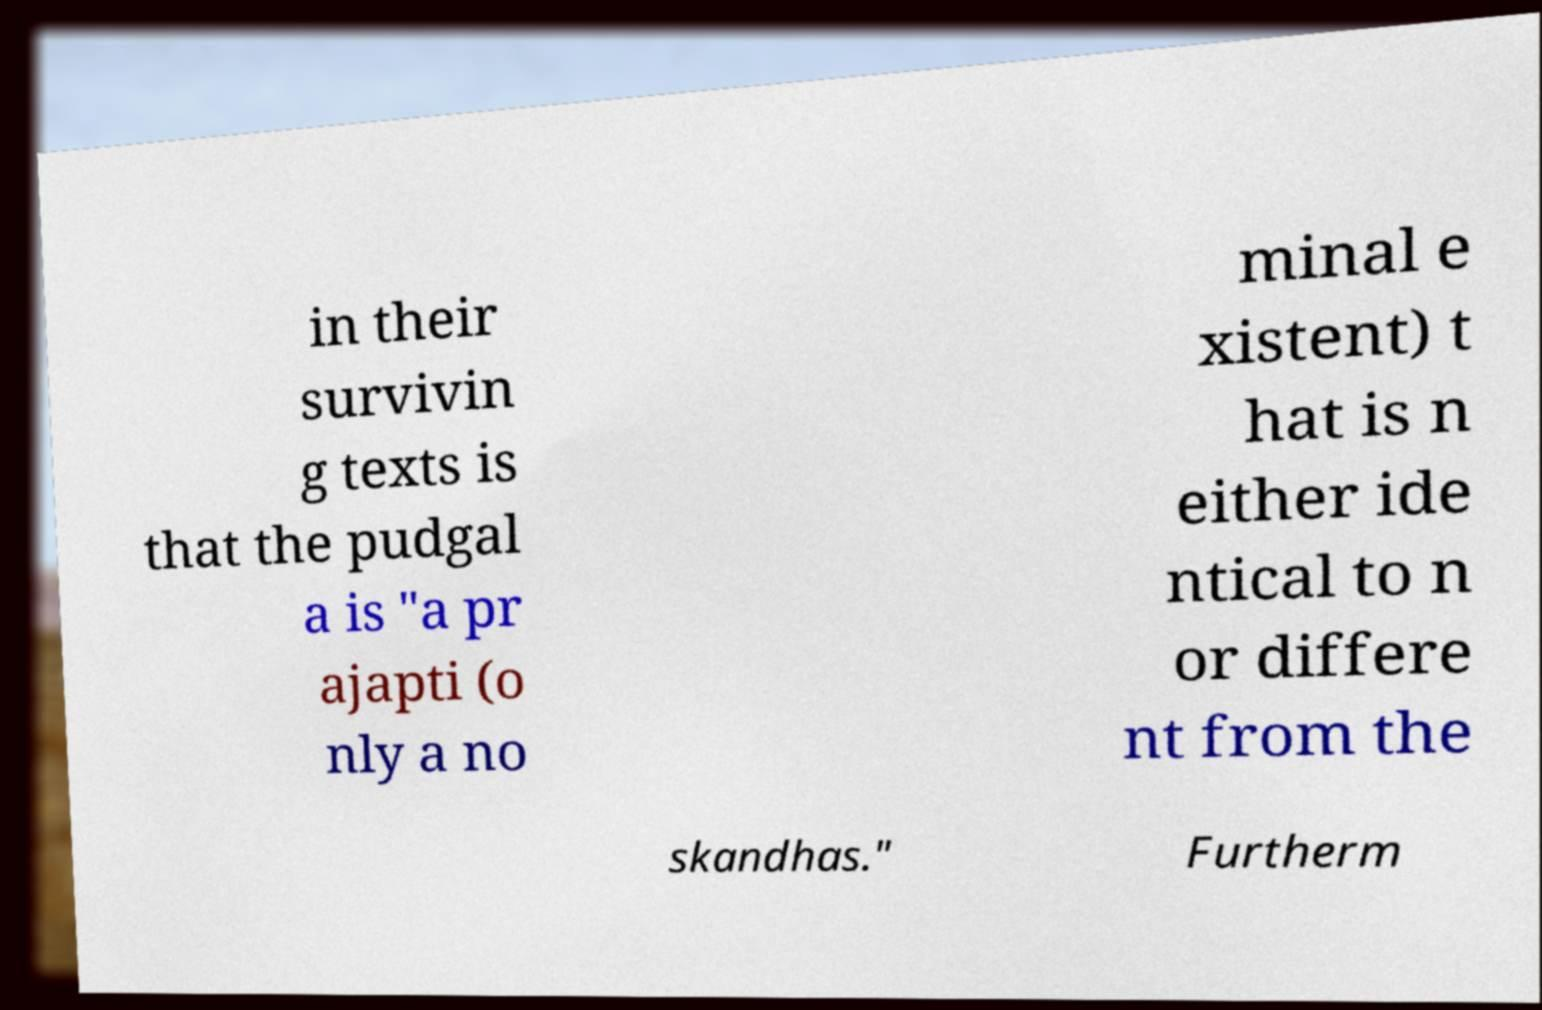Please identify and transcribe the text found in this image. in their survivin g texts is that the pudgal a is "a pr ajapti (o nly a no minal e xistent) t hat is n either ide ntical to n or differe nt from the skandhas." Furtherm 